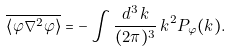Convert formula to latex. <formula><loc_0><loc_0><loc_500><loc_500>\overline { \left \langle \varphi \nabla ^ { 2 } \varphi \right \rangle } = - \int \frac { d ^ { 3 } \, k } { ( 2 \pi ) ^ { 3 } } \, k ^ { 2 } P _ { \varphi } ( k ) .</formula> 